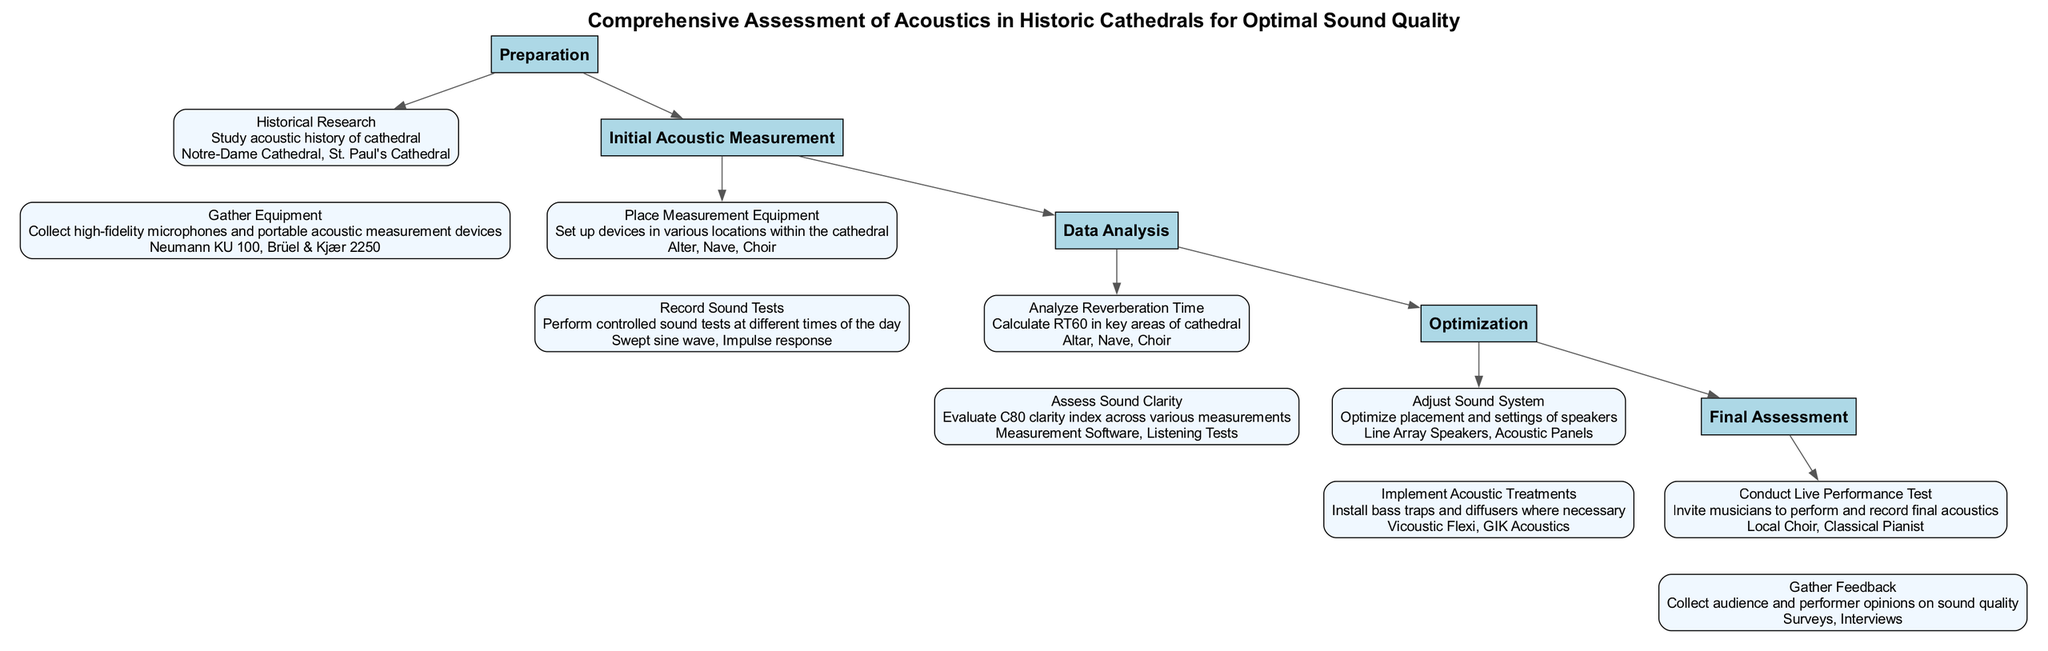What is the first step in the clinical pathway? The first step listed in the diagram is "Preparation," which is the initial phase of the pathway.
Answer: Preparation How many steps are there in the clinical pathway? The diagram shows a total of five steps ranging from "Preparation" to "Final Assessment."
Answer: 5 Which activity involves historical research? The activity associated with historical research is "Historical Research" under the "Preparation" step.
Answer: Historical Research What equipment is gathered in the "Preparation" step? The activity "Gather Equipment" in the "Preparation" step mentions collecting high-fidelity microphones and portable acoustic measurement devices.
Answer: High-fidelity microphones and portable acoustic measurement devices Which locations are used during the "Initial Acoustic Measurement"? The diagram lists "Alter," "Nave," and "Choir" as the specific locations where the measurement equipment is placed.
Answer: Alter, Nave, Choir What does RT60 refer to in the "Data Analysis" step? RT60 refers to "Reverberation Time," specifically calculated in key areas like "Altar," "Nave," and "Choir."
Answer: Reverberation Time In which step is live performance testing conducted? Live performance testing is conducted in the "Final Assessment" step.
Answer: Final Assessment What is assessed in terms of sound clarity? The diagram specifies evaluating "C80 clarity index" across various measurements for sound clarity assessment.
Answer: C80 clarity index What types of acoustic treatments are implemented during the "Optimization" step? The activity "Implement Acoustic Treatments" mentions installing bass traps and diffusers in necessary locations.
Answer: Bass traps and diffusers How is feedback gathered in the "Final Assessment" step? The diagram indicates that feedback is collected through "Surveys" and "Interviews" from both the audience and performers.
Answer: Surveys and Interviews 